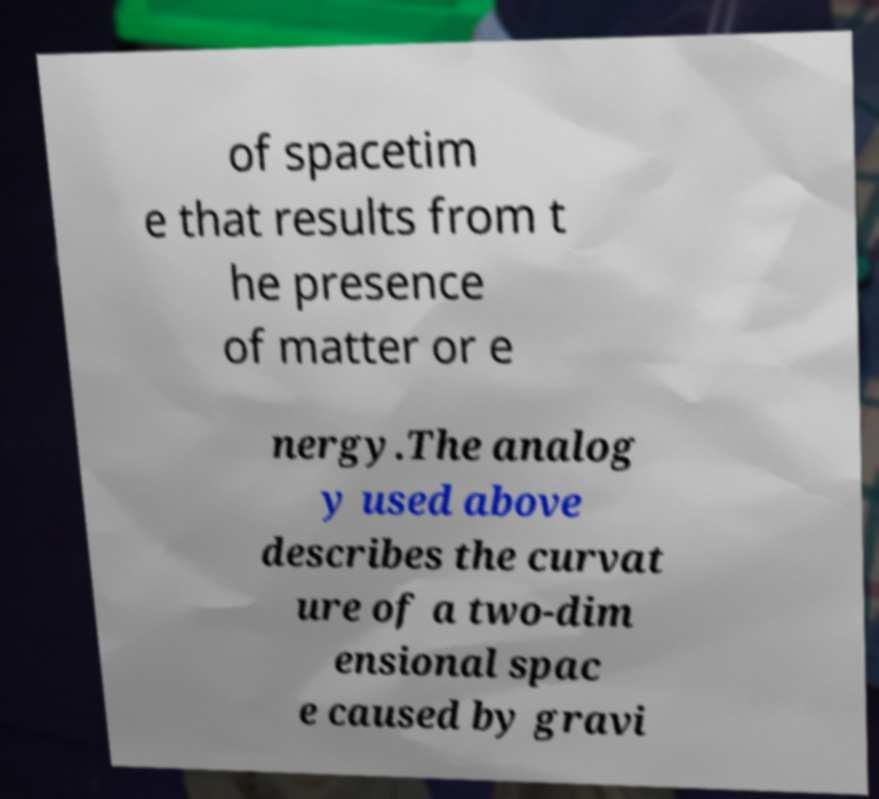Can you accurately transcribe the text from the provided image for me? of spacetim e that results from t he presence of matter or e nergy.The analog y used above describes the curvat ure of a two-dim ensional spac e caused by gravi 